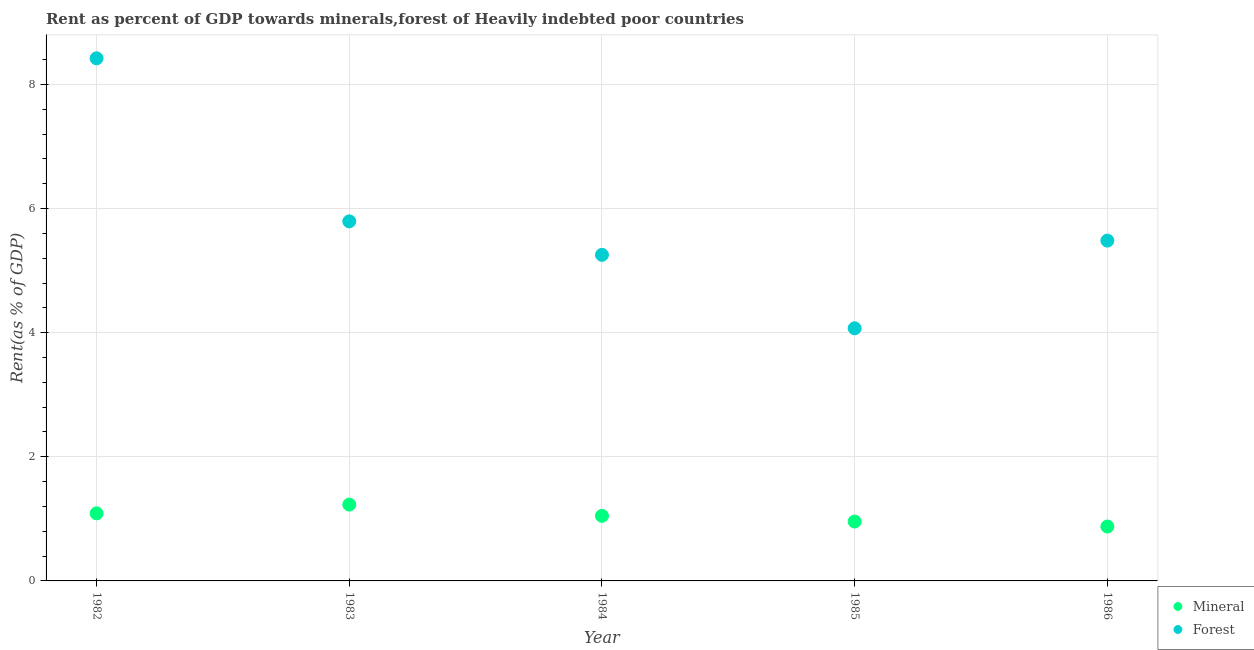What is the mineral rent in 1982?
Your response must be concise. 1.09. Across all years, what is the maximum forest rent?
Your answer should be compact. 8.42. Across all years, what is the minimum mineral rent?
Offer a terse response. 0.88. In which year was the forest rent maximum?
Ensure brevity in your answer.  1982. In which year was the mineral rent minimum?
Your answer should be compact. 1986. What is the total forest rent in the graph?
Ensure brevity in your answer.  29.03. What is the difference between the mineral rent in 1983 and that in 1984?
Your response must be concise. 0.18. What is the difference between the mineral rent in 1985 and the forest rent in 1983?
Your answer should be very brief. -4.84. What is the average mineral rent per year?
Make the answer very short. 1.04. In the year 1984, what is the difference between the mineral rent and forest rent?
Make the answer very short. -4.21. What is the ratio of the mineral rent in 1985 to that in 1986?
Offer a very short reply. 1.09. Is the difference between the forest rent in 1984 and 1985 greater than the difference between the mineral rent in 1984 and 1985?
Your answer should be very brief. Yes. What is the difference between the highest and the second highest forest rent?
Your response must be concise. 2.63. What is the difference between the highest and the lowest mineral rent?
Provide a short and direct response. 0.35. In how many years, is the forest rent greater than the average forest rent taken over all years?
Ensure brevity in your answer.  1. Does the forest rent monotonically increase over the years?
Your response must be concise. No. What is the difference between two consecutive major ticks on the Y-axis?
Your response must be concise. 2. Are the values on the major ticks of Y-axis written in scientific E-notation?
Offer a very short reply. No. What is the title of the graph?
Offer a terse response. Rent as percent of GDP towards minerals,forest of Heavily indebted poor countries. What is the label or title of the Y-axis?
Give a very brief answer. Rent(as % of GDP). What is the Rent(as % of GDP) in Mineral in 1982?
Your answer should be compact. 1.09. What is the Rent(as % of GDP) of Forest in 1982?
Offer a very short reply. 8.42. What is the Rent(as % of GDP) in Mineral in 1983?
Make the answer very short. 1.23. What is the Rent(as % of GDP) in Forest in 1983?
Give a very brief answer. 5.79. What is the Rent(as % of GDP) of Mineral in 1984?
Keep it short and to the point. 1.05. What is the Rent(as % of GDP) in Forest in 1984?
Provide a short and direct response. 5.25. What is the Rent(as % of GDP) in Mineral in 1985?
Keep it short and to the point. 0.96. What is the Rent(as % of GDP) of Forest in 1985?
Provide a succinct answer. 4.07. What is the Rent(as % of GDP) of Mineral in 1986?
Your answer should be very brief. 0.88. What is the Rent(as % of GDP) in Forest in 1986?
Your response must be concise. 5.48. Across all years, what is the maximum Rent(as % of GDP) in Mineral?
Ensure brevity in your answer.  1.23. Across all years, what is the maximum Rent(as % of GDP) in Forest?
Provide a short and direct response. 8.42. Across all years, what is the minimum Rent(as % of GDP) in Mineral?
Give a very brief answer. 0.88. Across all years, what is the minimum Rent(as % of GDP) in Forest?
Give a very brief answer. 4.07. What is the total Rent(as % of GDP) in Mineral in the graph?
Your response must be concise. 5.2. What is the total Rent(as % of GDP) in Forest in the graph?
Your response must be concise. 29.03. What is the difference between the Rent(as % of GDP) in Mineral in 1982 and that in 1983?
Keep it short and to the point. -0.14. What is the difference between the Rent(as % of GDP) of Forest in 1982 and that in 1983?
Give a very brief answer. 2.63. What is the difference between the Rent(as % of GDP) in Mineral in 1982 and that in 1984?
Give a very brief answer. 0.04. What is the difference between the Rent(as % of GDP) in Forest in 1982 and that in 1984?
Keep it short and to the point. 3.17. What is the difference between the Rent(as % of GDP) in Mineral in 1982 and that in 1985?
Ensure brevity in your answer.  0.13. What is the difference between the Rent(as % of GDP) of Forest in 1982 and that in 1985?
Ensure brevity in your answer.  4.35. What is the difference between the Rent(as % of GDP) of Mineral in 1982 and that in 1986?
Your answer should be compact. 0.21. What is the difference between the Rent(as % of GDP) in Forest in 1982 and that in 1986?
Your answer should be very brief. 2.94. What is the difference between the Rent(as % of GDP) in Mineral in 1983 and that in 1984?
Ensure brevity in your answer.  0.18. What is the difference between the Rent(as % of GDP) in Forest in 1983 and that in 1984?
Provide a succinct answer. 0.54. What is the difference between the Rent(as % of GDP) of Mineral in 1983 and that in 1985?
Offer a terse response. 0.27. What is the difference between the Rent(as % of GDP) in Forest in 1983 and that in 1985?
Offer a very short reply. 1.72. What is the difference between the Rent(as % of GDP) of Mineral in 1983 and that in 1986?
Your response must be concise. 0.35. What is the difference between the Rent(as % of GDP) of Forest in 1983 and that in 1986?
Give a very brief answer. 0.31. What is the difference between the Rent(as % of GDP) in Mineral in 1984 and that in 1985?
Give a very brief answer. 0.09. What is the difference between the Rent(as % of GDP) in Forest in 1984 and that in 1985?
Your response must be concise. 1.18. What is the difference between the Rent(as % of GDP) in Mineral in 1984 and that in 1986?
Keep it short and to the point. 0.17. What is the difference between the Rent(as % of GDP) of Forest in 1984 and that in 1986?
Your answer should be very brief. -0.23. What is the difference between the Rent(as % of GDP) of Mineral in 1985 and that in 1986?
Offer a very short reply. 0.08. What is the difference between the Rent(as % of GDP) in Forest in 1985 and that in 1986?
Give a very brief answer. -1.41. What is the difference between the Rent(as % of GDP) in Mineral in 1982 and the Rent(as % of GDP) in Forest in 1983?
Offer a terse response. -4.71. What is the difference between the Rent(as % of GDP) of Mineral in 1982 and the Rent(as % of GDP) of Forest in 1984?
Make the answer very short. -4.17. What is the difference between the Rent(as % of GDP) of Mineral in 1982 and the Rent(as % of GDP) of Forest in 1985?
Your response must be concise. -2.98. What is the difference between the Rent(as % of GDP) of Mineral in 1982 and the Rent(as % of GDP) of Forest in 1986?
Make the answer very short. -4.4. What is the difference between the Rent(as % of GDP) in Mineral in 1983 and the Rent(as % of GDP) in Forest in 1984?
Your answer should be compact. -4.02. What is the difference between the Rent(as % of GDP) in Mineral in 1983 and the Rent(as % of GDP) in Forest in 1985?
Offer a very short reply. -2.84. What is the difference between the Rent(as % of GDP) in Mineral in 1983 and the Rent(as % of GDP) in Forest in 1986?
Make the answer very short. -4.25. What is the difference between the Rent(as % of GDP) of Mineral in 1984 and the Rent(as % of GDP) of Forest in 1985?
Keep it short and to the point. -3.02. What is the difference between the Rent(as % of GDP) in Mineral in 1984 and the Rent(as % of GDP) in Forest in 1986?
Keep it short and to the point. -4.44. What is the difference between the Rent(as % of GDP) in Mineral in 1985 and the Rent(as % of GDP) in Forest in 1986?
Your response must be concise. -4.53. What is the average Rent(as % of GDP) in Mineral per year?
Keep it short and to the point. 1.04. What is the average Rent(as % of GDP) in Forest per year?
Give a very brief answer. 5.81. In the year 1982, what is the difference between the Rent(as % of GDP) in Mineral and Rent(as % of GDP) in Forest?
Your answer should be compact. -7.33. In the year 1983, what is the difference between the Rent(as % of GDP) in Mineral and Rent(as % of GDP) in Forest?
Provide a short and direct response. -4.56. In the year 1984, what is the difference between the Rent(as % of GDP) of Mineral and Rent(as % of GDP) of Forest?
Make the answer very short. -4.21. In the year 1985, what is the difference between the Rent(as % of GDP) of Mineral and Rent(as % of GDP) of Forest?
Provide a short and direct response. -3.11. In the year 1986, what is the difference between the Rent(as % of GDP) of Mineral and Rent(as % of GDP) of Forest?
Provide a short and direct response. -4.61. What is the ratio of the Rent(as % of GDP) of Mineral in 1982 to that in 1983?
Provide a succinct answer. 0.89. What is the ratio of the Rent(as % of GDP) of Forest in 1982 to that in 1983?
Provide a succinct answer. 1.45. What is the ratio of the Rent(as % of GDP) of Mineral in 1982 to that in 1984?
Your response must be concise. 1.04. What is the ratio of the Rent(as % of GDP) in Forest in 1982 to that in 1984?
Offer a terse response. 1.6. What is the ratio of the Rent(as % of GDP) in Mineral in 1982 to that in 1985?
Provide a succinct answer. 1.14. What is the ratio of the Rent(as % of GDP) in Forest in 1982 to that in 1985?
Provide a short and direct response. 2.07. What is the ratio of the Rent(as % of GDP) in Mineral in 1982 to that in 1986?
Offer a terse response. 1.24. What is the ratio of the Rent(as % of GDP) in Forest in 1982 to that in 1986?
Your answer should be compact. 1.54. What is the ratio of the Rent(as % of GDP) of Mineral in 1983 to that in 1984?
Keep it short and to the point. 1.17. What is the ratio of the Rent(as % of GDP) in Forest in 1983 to that in 1984?
Keep it short and to the point. 1.1. What is the ratio of the Rent(as % of GDP) in Mineral in 1983 to that in 1985?
Offer a terse response. 1.29. What is the ratio of the Rent(as % of GDP) of Forest in 1983 to that in 1985?
Ensure brevity in your answer.  1.42. What is the ratio of the Rent(as % of GDP) in Mineral in 1983 to that in 1986?
Ensure brevity in your answer.  1.4. What is the ratio of the Rent(as % of GDP) in Forest in 1983 to that in 1986?
Ensure brevity in your answer.  1.06. What is the ratio of the Rent(as % of GDP) of Mineral in 1984 to that in 1985?
Provide a short and direct response. 1.1. What is the ratio of the Rent(as % of GDP) in Forest in 1984 to that in 1985?
Your answer should be very brief. 1.29. What is the ratio of the Rent(as % of GDP) in Mineral in 1984 to that in 1986?
Make the answer very short. 1.2. What is the ratio of the Rent(as % of GDP) of Forest in 1984 to that in 1986?
Your answer should be compact. 0.96. What is the ratio of the Rent(as % of GDP) in Mineral in 1985 to that in 1986?
Your answer should be compact. 1.09. What is the ratio of the Rent(as % of GDP) in Forest in 1985 to that in 1986?
Give a very brief answer. 0.74. What is the difference between the highest and the second highest Rent(as % of GDP) of Mineral?
Your answer should be compact. 0.14. What is the difference between the highest and the second highest Rent(as % of GDP) in Forest?
Provide a succinct answer. 2.63. What is the difference between the highest and the lowest Rent(as % of GDP) in Mineral?
Ensure brevity in your answer.  0.35. What is the difference between the highest and the lowest Rent(as % of GDP) of Forest?
Offer a very short reply. 4.35. 